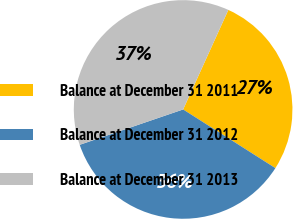<chart> <loc_0><loc_0><loc_500><loc_500><pie_chart><fcel>Balance at December 31 2011<fcel>Balance at December 31 2012<fcel>Balance at December 31 2013<nl><fcel>27.23%<fcel>35.74%<fcel>37.03%<nl></chart> 